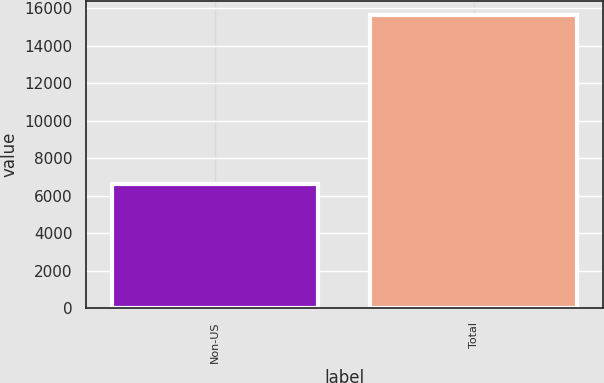Convert chart to OTSL. <chart><loc_0><loc_0><loc_500><loc_500><bar_chart><fcel>Non-US<fcel>Total<nl><fcel>6630<fcel>15622<nl></chart> 